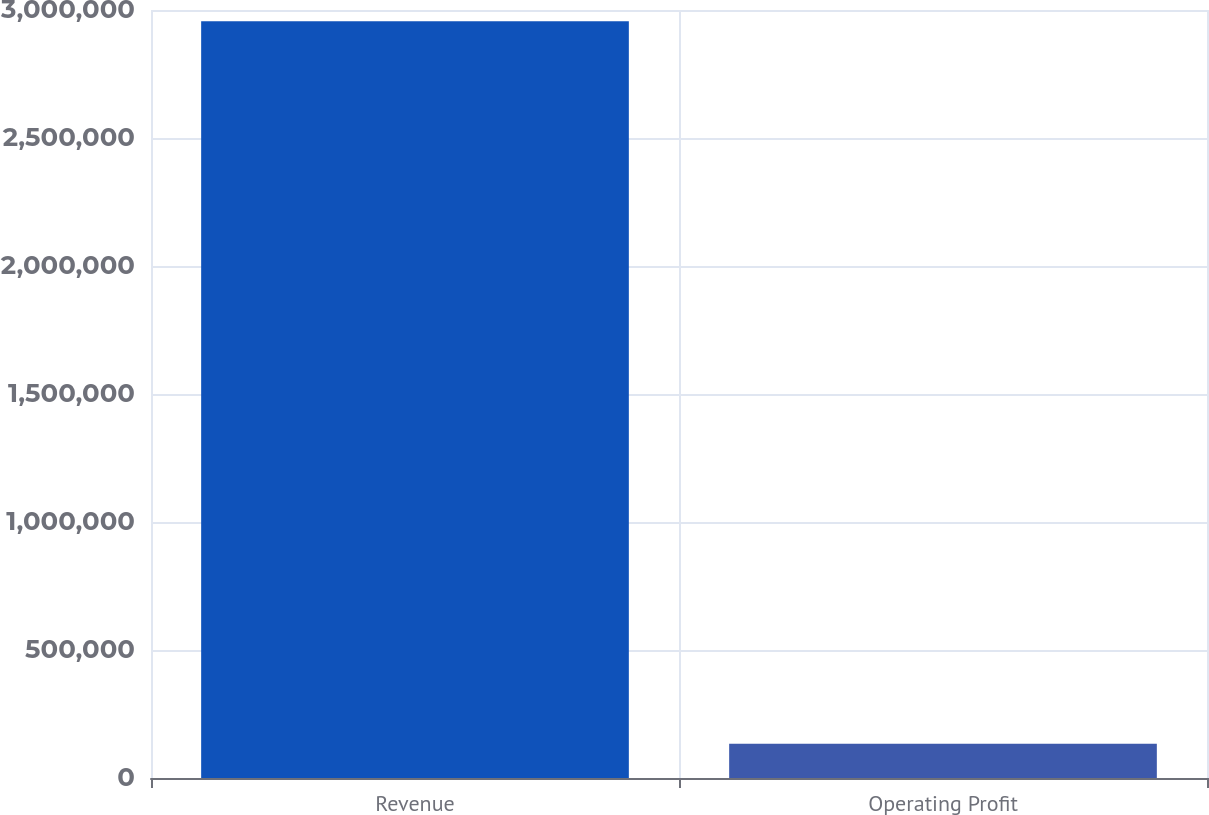Convert chart. <chart><loc_0><loc_0><loc_500><loc_500><bar_chart><fcel>Revenue<fcel>Operating Profit<nl><fcel>2.95639e+06<fcel>134230<nl></chart> 